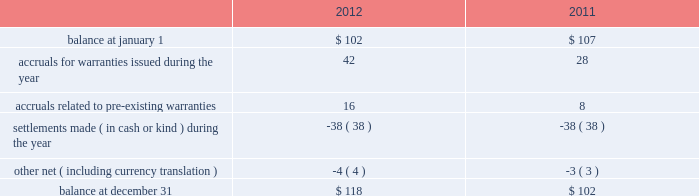Masco corporation notes to consolidated financial statements ( continued ) t .
Other commitments and contingencies litigation .
We are subject to claims , charges , litigation and other proceedings in the ordinary course of our business , including those arising from or related to contractual matters , intellectual property , personal injury , environmental matters , product liability , construction defect , insurance coverage , personnel and employment disputes and other matters , including class actions .
We believe we have adequate defenses in these matters and that the outcome of these matters is not likely to have a material adverse effect on us .
However , there is no assurance that we will prevail in these matters , and we could in the future incur judgments , enter into settlements of claims or revise our expectations regarding the outcome of these matters , which could materially impact our results of operations .
In july 2012 , the company reached a settlement agreement related to the columbus drywall litigation .
The company and its insulation installation companies named in the suit agreed to pay $ 75 million in return for dismissal with prejudice and full release of all claims .
The company and its insulation installation companies continue to deny that the challenged conduct was unlawful and admit no wrongdoing as part of the settlement .
A settlement was reached to eliminate the considerable expense and uncertainty of this lawsuit .
The company recorded the settlement expense in the second quarter of 2012 and the amount was paid in the fourth quarter of 2012 .
Warranty .
At the time of sale , the company accrues a warranty liability for the estimated cost to provide products , parts or services to repair or replace products in satisfaction of warranty obligations .
During the third quarter of 2012 , a business in the other specialty products segment recorded a $ 12 million increase in expected future warranty claims resulting from the completion of an analysis prepared by the company based upon its periodic assessment of recent business unit specific operating trends including , among others , home ownership demographics , sales volumes , manufacturing quality , an analysis of recent warranty claim activity and an estimate of current costs to service anticipated claims .
Changes in the company 2019s warranty liability were as follows , in millions: .
Investments .
With respect to the company 2019s investments in private equity funds , the company had , at december 31 , 2012 , commitments to contribute up to $ 19 million of additional capital to such funds representing the company 2019s aggregate capital commitment to such funds less capital contributions made to date .
The company is contractually obligated to make additional capital contributions to certain of its private equity funds upon receipt of a capital call from the private equity fund .
The company has no control over when or if the capital calls will occur .
Capital calls are funded in cash and generally result in an increase in the carrying value of the company 2019s investment in the private equity fund when paid. .
What was the percentage change in the company's warranty liability from 2011 to 2012? 
Computations: ((118 - 102) / 102)
Answer: 0.15686. 